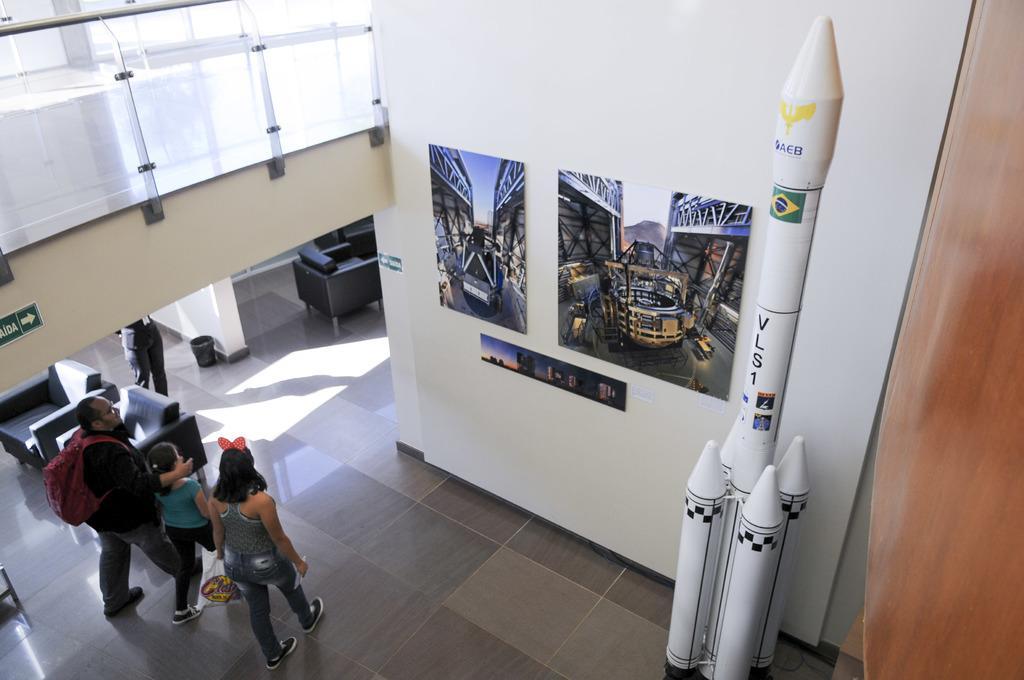How would you summarize this image in a sentence or two? In this image we can see people walking on the floor. There is a wall with posters. There is a depiction of a rocket to the right side of the image and there is a wooden wall. At the bottom of the image there is floor. There are chairs. 